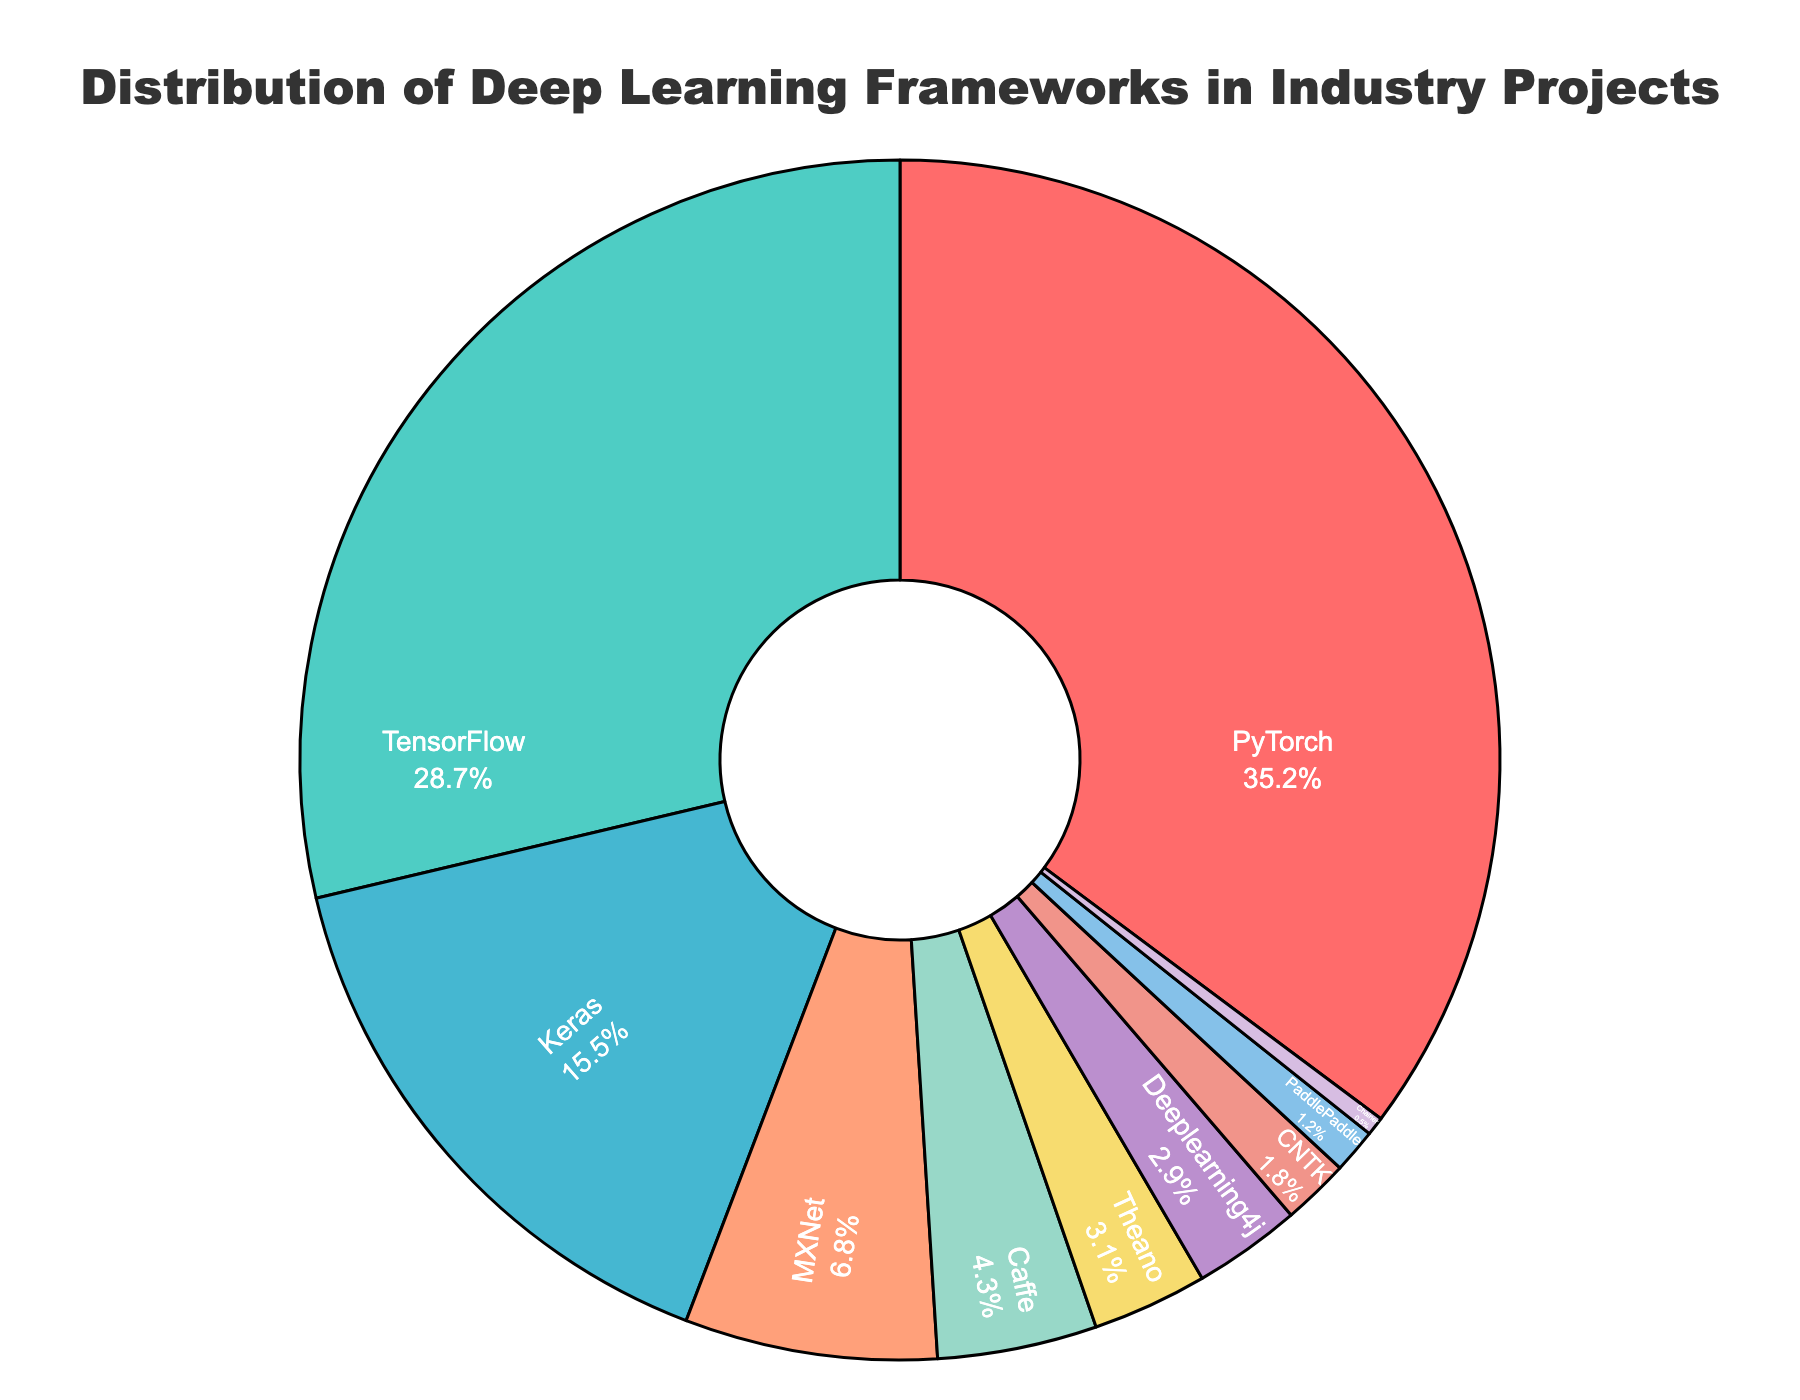What's the most commonly used deep learning framework in industry projects? By looking at the pie chart, identify which segment is the largest and has the highest percentage. In this case, the largest segment represents PyTorch with 35.2%.
Answer: PyTorch What is the combined percentage of projects using Keras and TensorFlow? Add the percentages of Keras and TensorFlow. The chart shows Keras at 15.5% and TensorFlow at 28.7%, which adds up to 44.2%.
Answer: 44.2% Which framework is used less frequently in industry projects, CNTK or PaddlePaddle? Compare the percentages of CNTK and PaddlePaddle. CNTK has 1.8%, and PaddlePaddle has 1.2%, making PaddlePaddle the less frequently used framework.
Answer: PaddlePaddle How much more popular is PyTorch compared to MXNet? Subtract the percentage of MXNet from that of PyTorch. PyTorch is 35.2%, and MXNet is 6.8%, so the difference is 35.2% - 6.8% = 28.4%.
Answer: 28.4% Which frameworks together account for less than 10% of the total usage? Identify segments where the percentage is less than 10% and sum their values. CNTK (1.8%), Deeplearning4j (2.9%), Theano (3.1%), PaddlePaddle (1.2%), and Chainer (0.5%) together make 9.5%.
Answer: CNTK, Deeplearning4j, Theano, PaddlePaddle, Chainer What's the difference in usage between the second most and the third most popular frameworks? Determine the percentages of the second and third highest usage rates, which are TensorFlow (28.7%) and Keras (15.5%). The difference is 28.7% - 15.5% = 13.2%.
Answer: 13.2% Which framework has just slightly more usage than Theano? Compare the percentages close to Theano's 3.1%. Deeplearning4j, which has 2.9%, and Theano are comparable, with Theano being slightly higher. Therefore, no framework is slightly higher, only slightly lower.
Answer: None How would the pie chart appear if TensorFlow's percentage was equally split between TensorFlow and Keras? Adding half of TensorFlow’s 28.7% to Keras, we get 14.35% + 15.5% = 29.85% for Keras. TensorFlow’s remaining percentage would be 14.35%.
Answer: TensorFlow: 14.35%, Keras: 29.85% If Caffe’s percentage doubled, how would its new percentage compare to MXNet? Double Caffe’s percentage from 4.3% to 8.6%. Compare this with MXNet’s 6.8%. The new percentage of Caffe would be higher than that of MXNet.
Answer: Caffe new is higher 